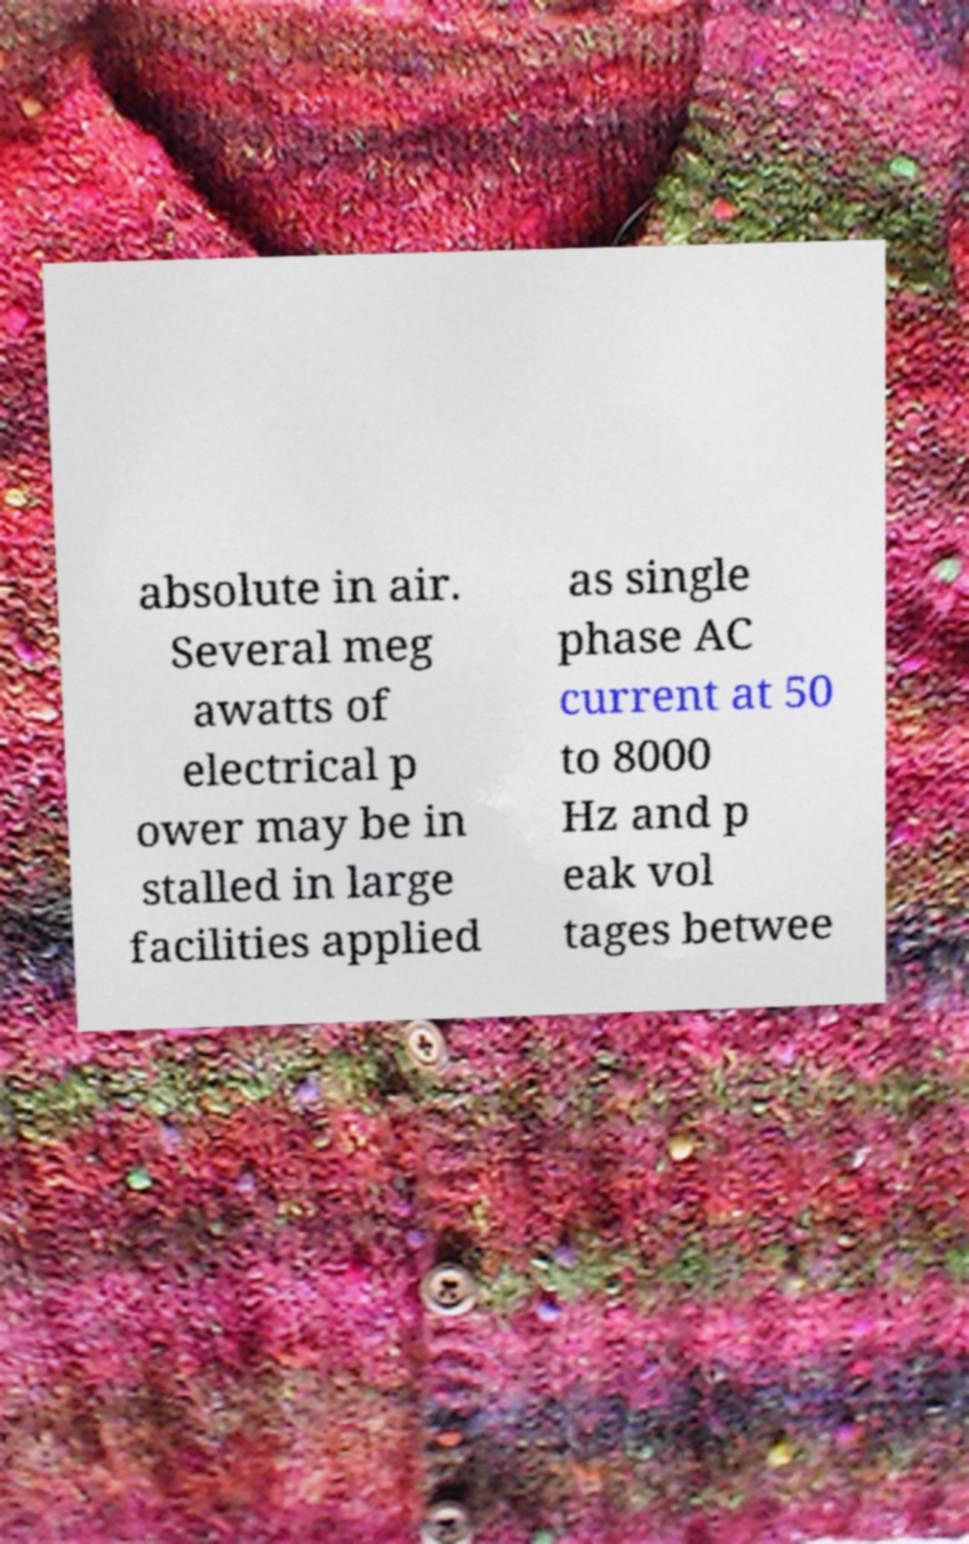What messages or text are displayed in this image? I need them in a readable, typed format. absolute in air. Several meg awatts of electrical p ower may be in stalled in large facilities applied as single phase AC current at 50 to 8000 Hz and p eak vol tages betwee 